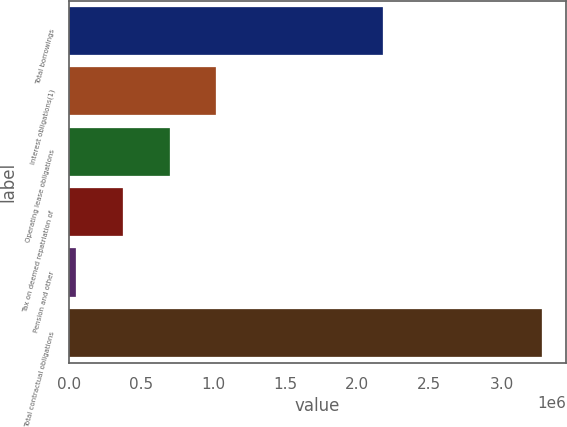<chart> <loc_0><loc_0><loc_500><loc_500><bar_chart><fcel>Total borrowings<fcel>Interest obligations(1)<fcel>Operating lease obligations<fcel>Tax on deemed repatriation of<fcel>Pension and other<fcel>Total contractual obligations<nl><fcel>2.1765e+06<fcel>1.02125e+06<fcel>698022<fcel>374796<fcel>51571<fcel>3.28382e+06<nl></chart> 